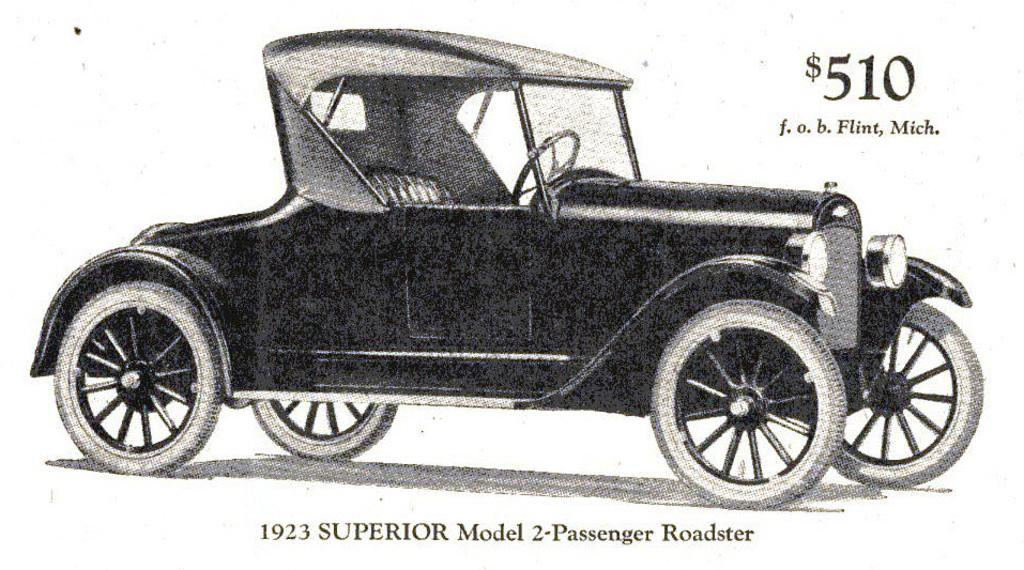What is featured on the poster in the image? There is a poster in the image, and it has text on it. What can be seen on the ground in the image? A car is parked on the ground in the image. What is the color scheme of the image? The image is in black and white color. Is there a cave visible in the image? No, there is no cave present in the image. How does the car smash through the poster in the image? The car does not smash through the poster in the image; it is parked on the ground. 